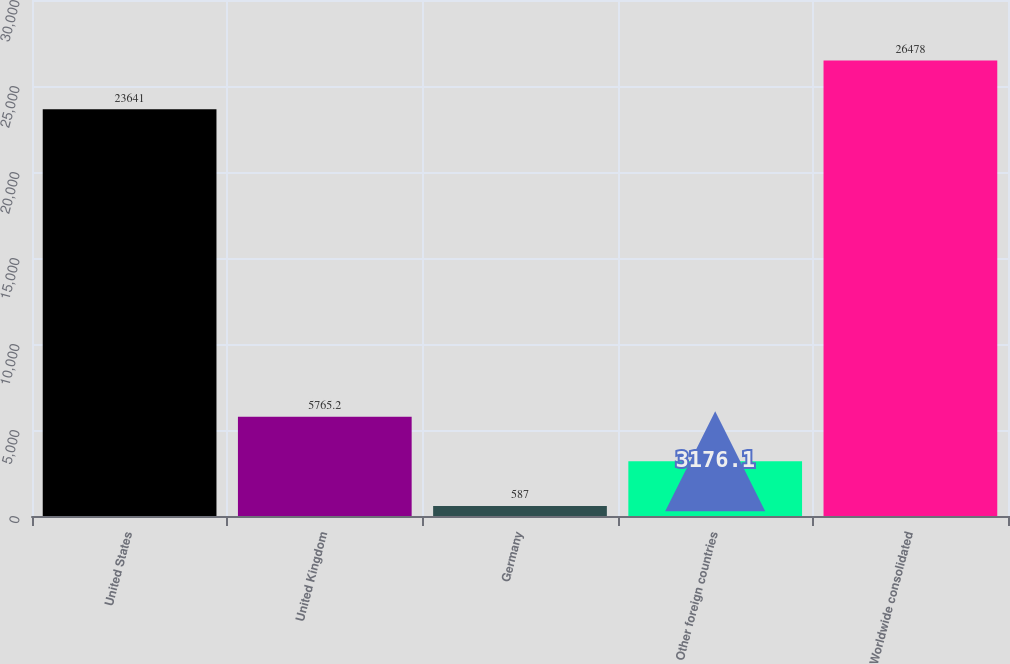<chart> <loc_0><loc_0><loc_500><loc_500><bar_chart><fcel>United States<fcel>United Kingdom<fcel>Germany<fcel>Other foreign countries<fcel>Worldwide consolidated<nl><fcel>23641<fcel>5765.2<fcel>587<fcel>3176.1<fcel>26478<nl></chart> 